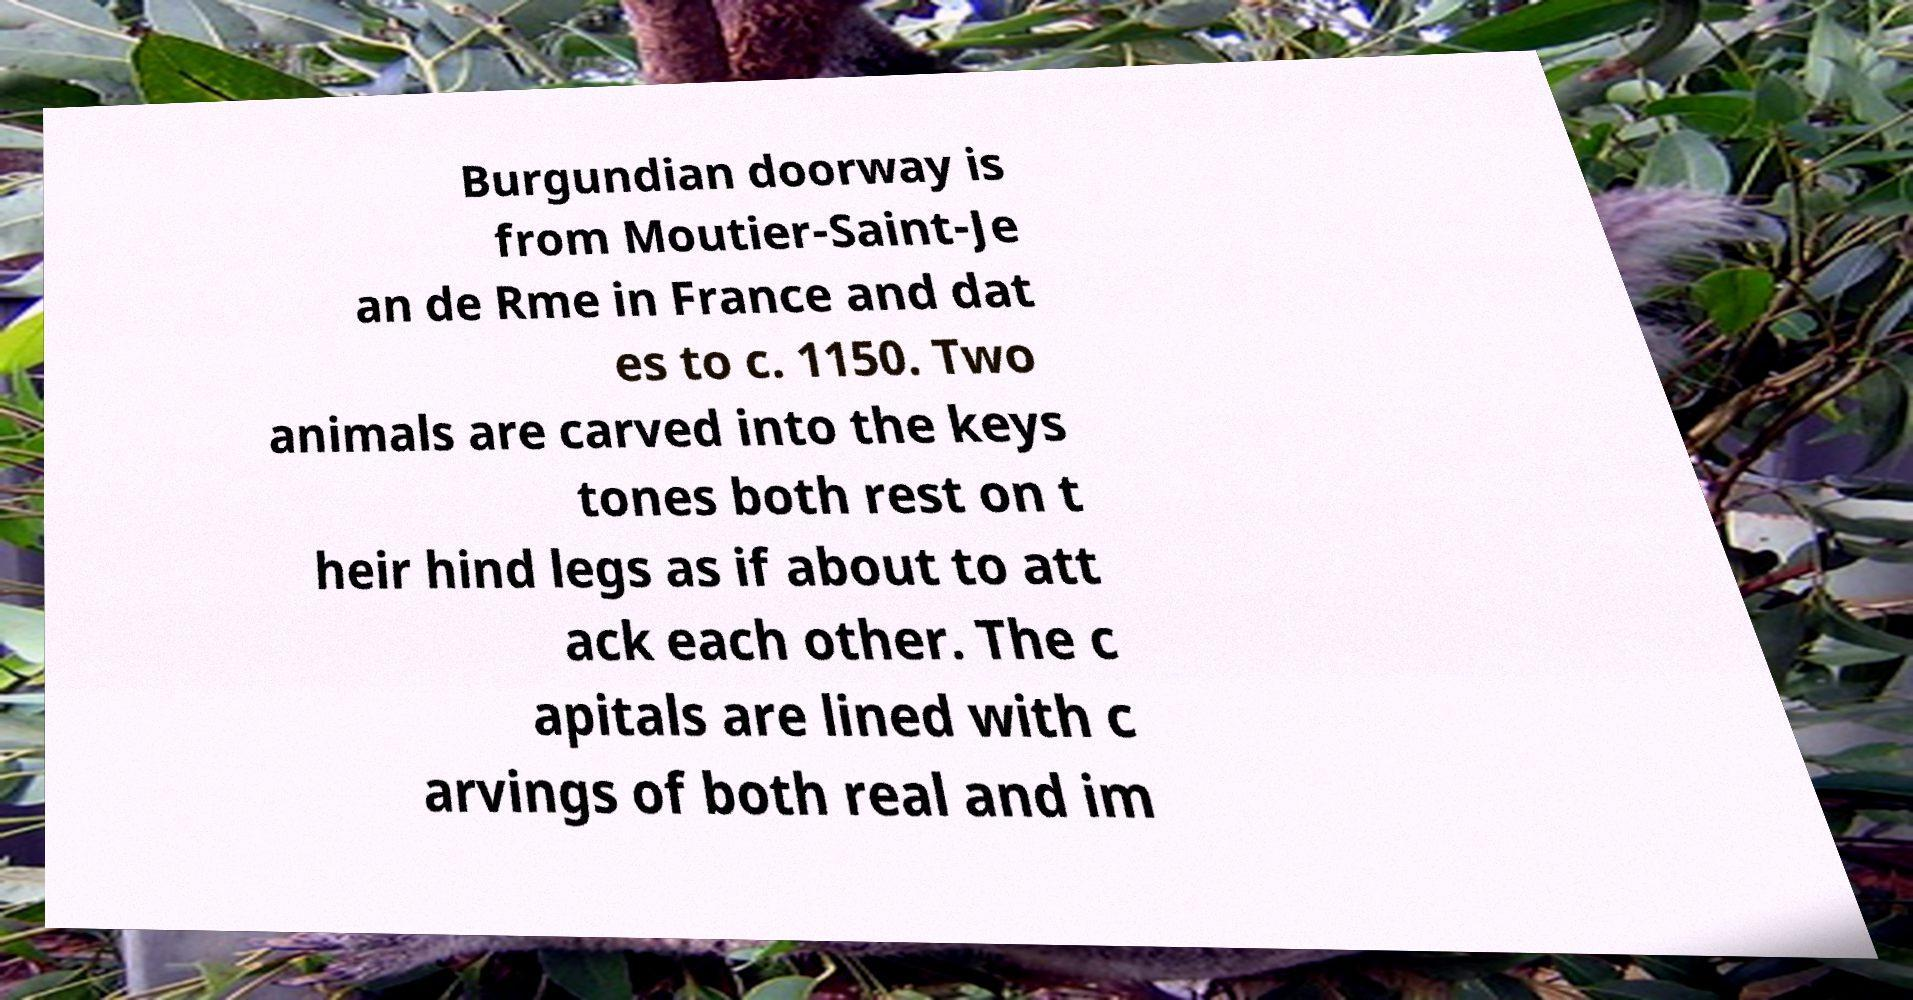Please identify and transcribe the text found in this image. Burgundian doorway is from Moutier-Saint-Je an de Rme in France and dat es to c. 1150. Two animals are carved into the keys tones both rest on t heir hind legs as if about to att ack each other. The c apitals are lined with c arvings of both real and im 